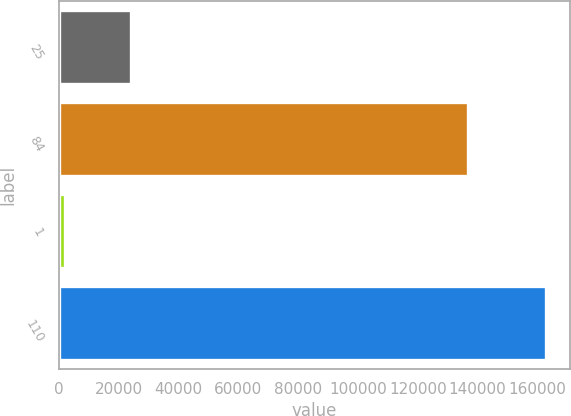<chart> <loc_0><loc_0><loc_500><loc_500><bar_chart><fcel>25<fcel>84<fcel>1<fcel>110<nl><fcel>24111<fcel>136752<fcel>1977<fcel>162840<nl></chart> 